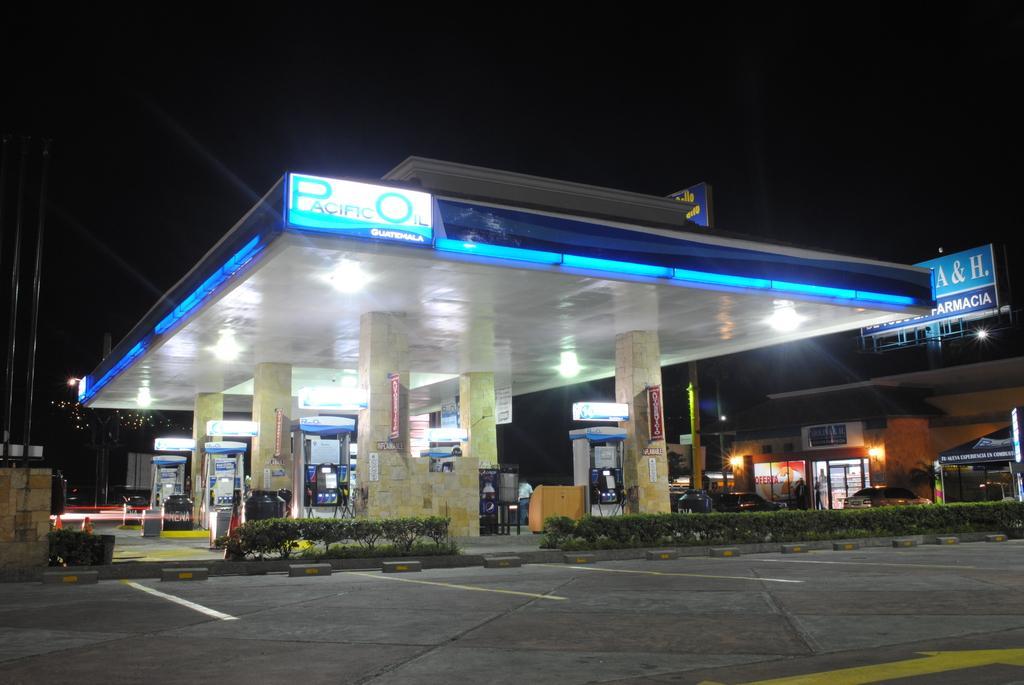Could you give a brief overview of what you see in this image? This image consists of a fuel station. At the bottom, there is a road. In the middle, there are plants. At the top, there is a sky. 